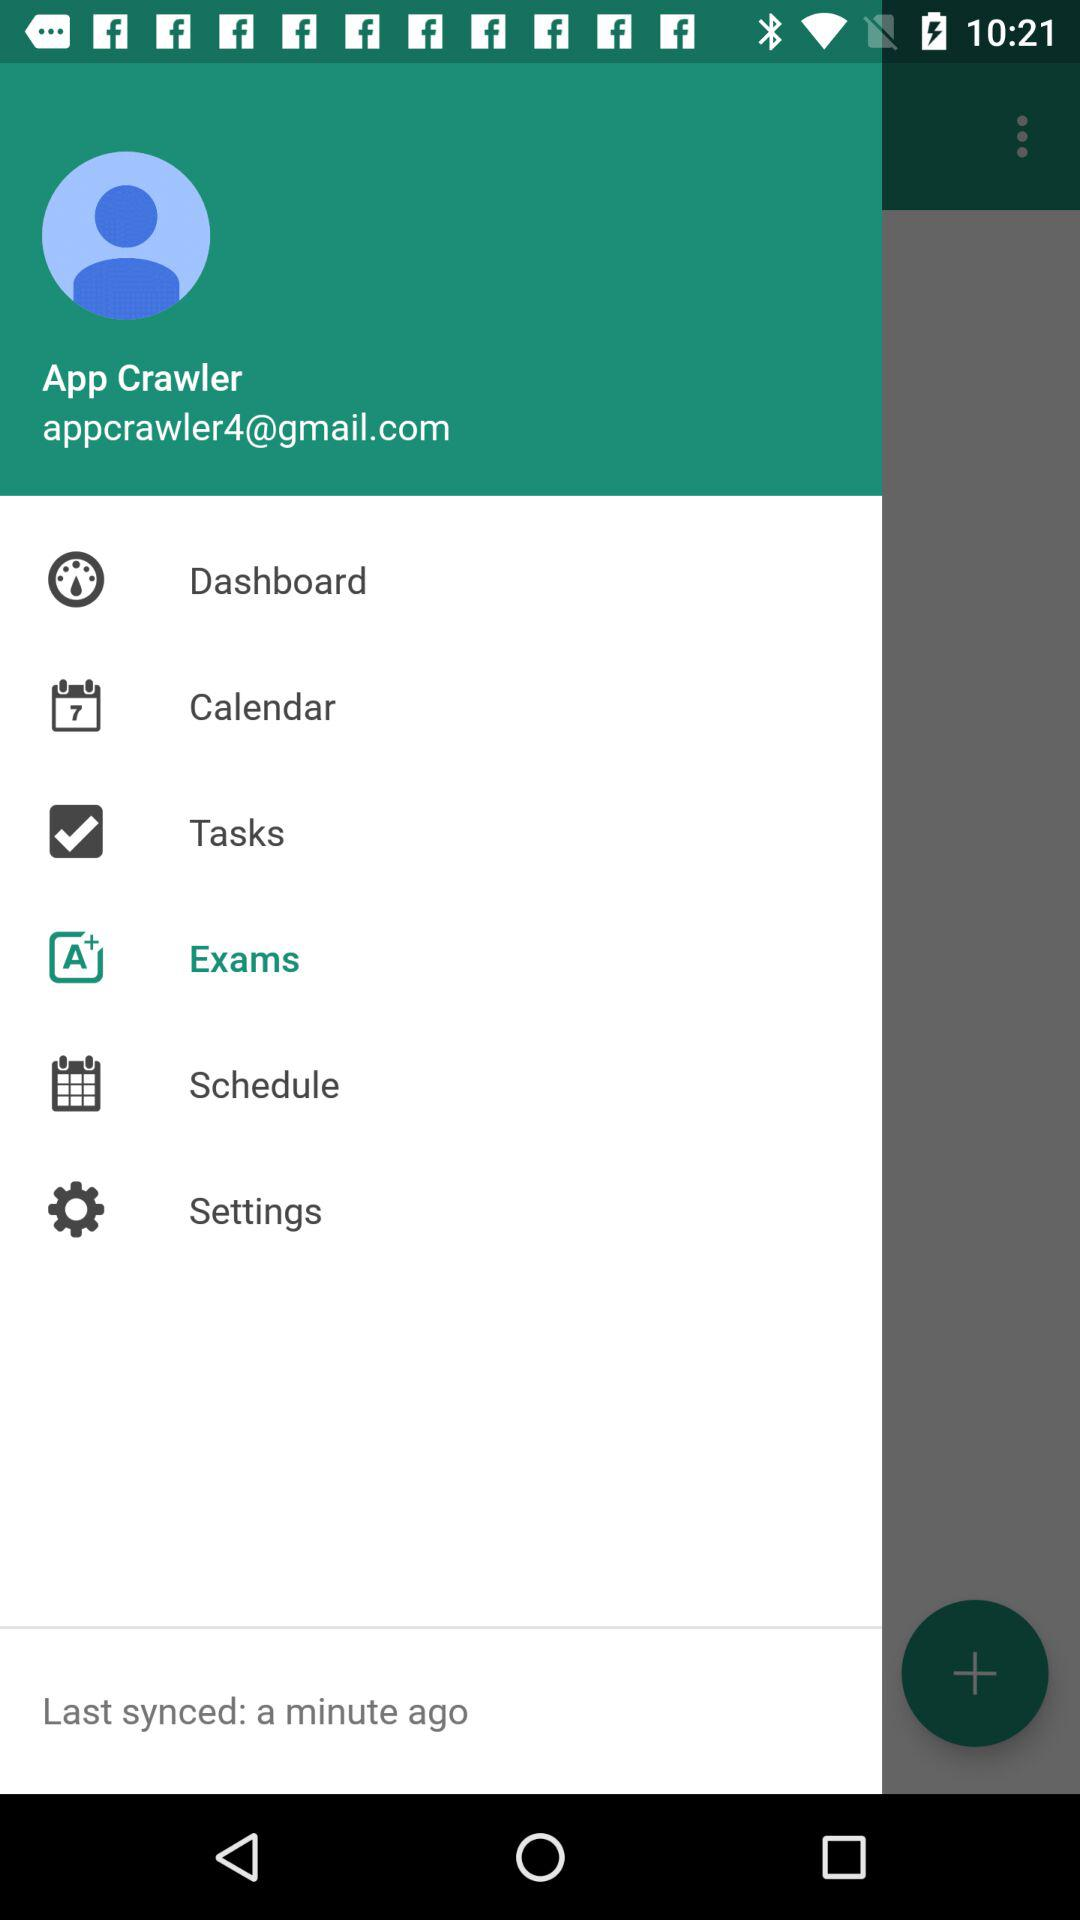How many seconds ago was the last sync?
Answer the question using a single word or phrase. 60 